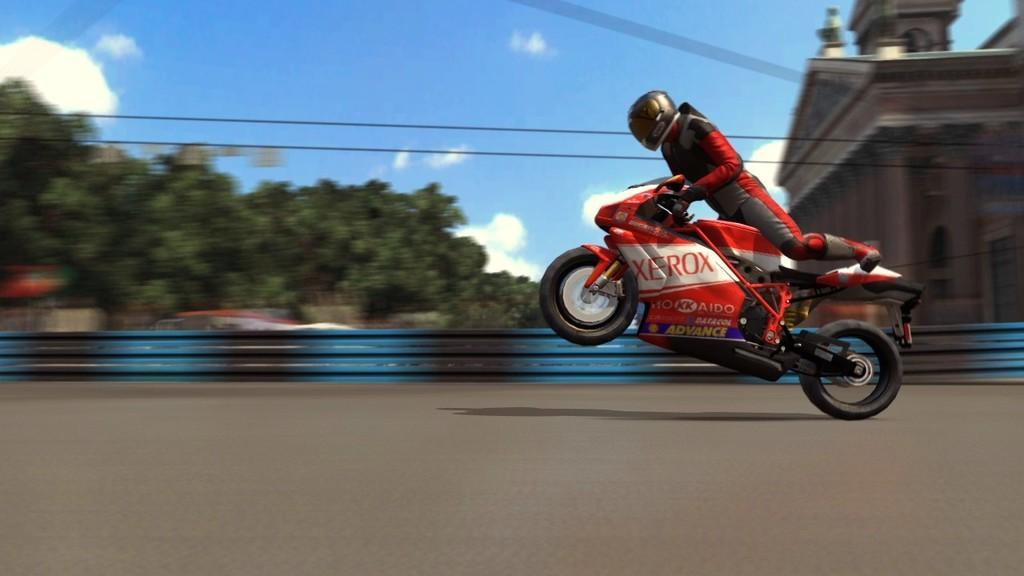In one or two sentences, can you explain what this image depicts? In this picture we can see a person wore a helmet and riding a motorbike on the road, trees, building and in the background we can see the sky with clouds. 